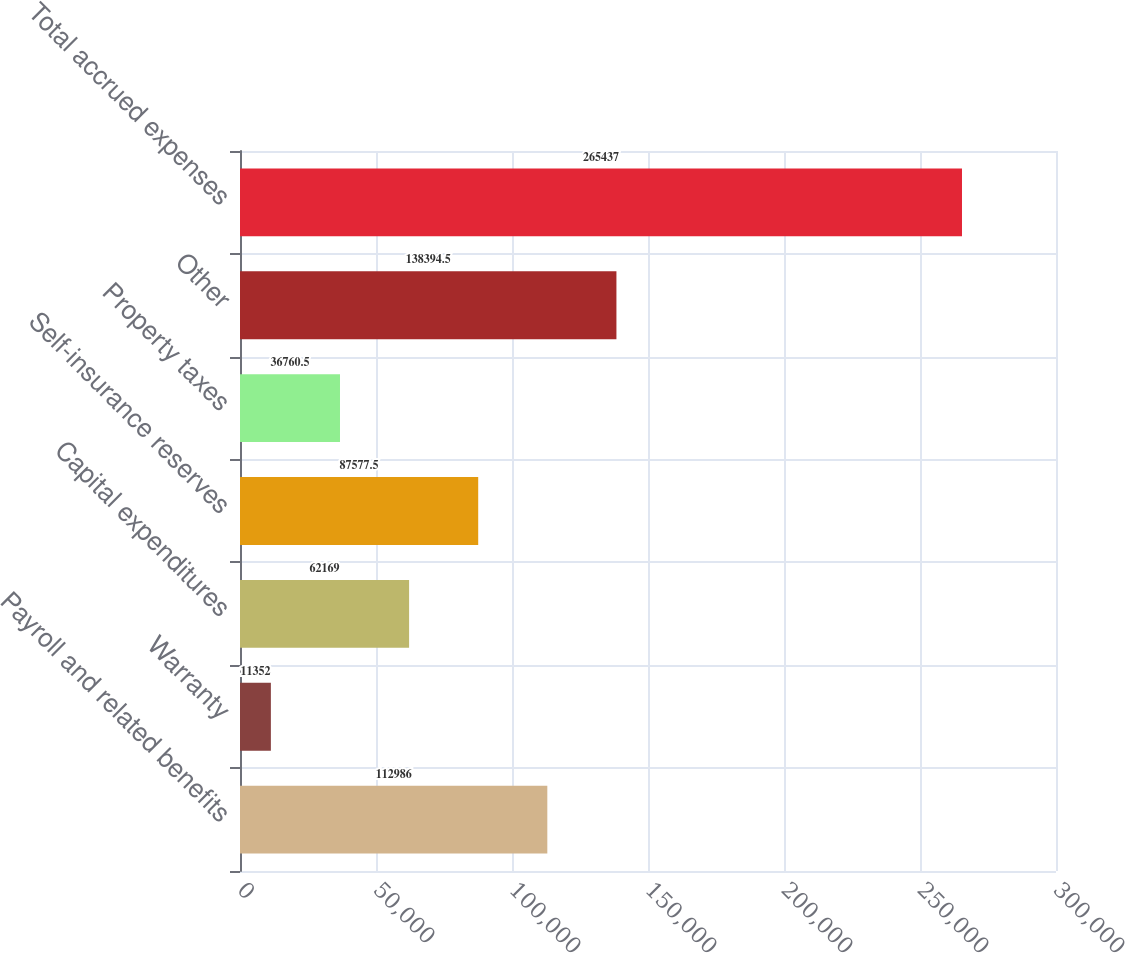Convert chart to OTSL. <chart><loc_0><loc_0><loc_500><loc_500><bar_chart><fcel>Payroll and related benefits<fcel>Warranty<fcel>Capital expenditures<fcel>Self-insurance reserves<fcel>Property taxes<fcel>Other<fcel>Total accrued expenses<nl><fcel>112986<fcel>11352<fcel>62169<fcel>87577.5<fcel>36760.5<fcel>138394<fcel>265437<nl></chart> 